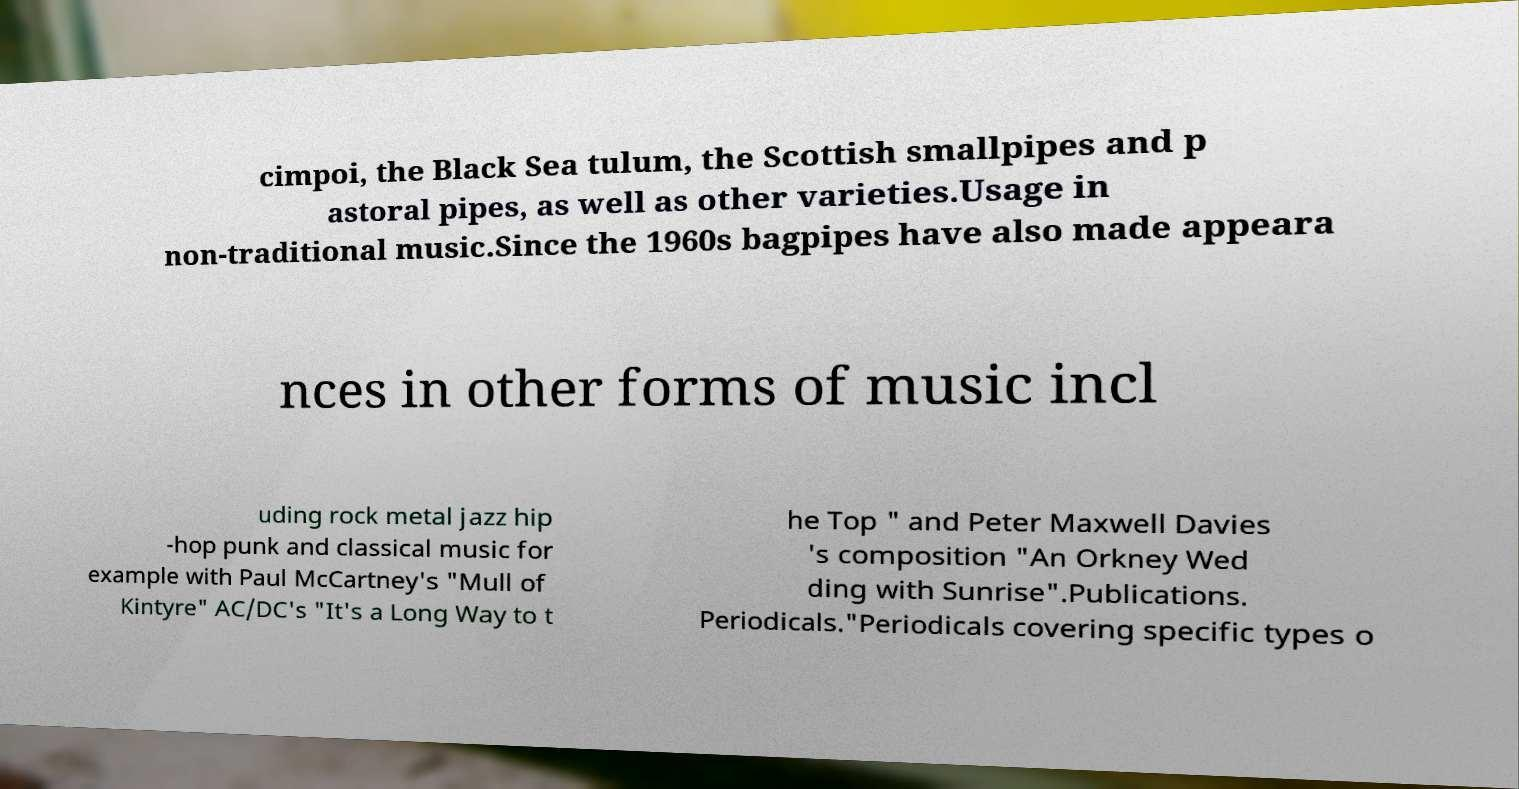Please identify and transcribe the text found in this image. cimpoi, the Black Sea tulum, the Scottish smallpipes and p astoral pipes, as well as other varieties.Usage in non-traditional music.Since the 1960s bagpipes have also made appeara nces in other forms of music incl uding rock metal jazz hip -hop punk and classical music for example with Paul McCartney's "Mull of Kintyre" AC/DC's "It's a Long Way to t he Top " and Peter Maxwell Davies 's composition "An Orkney Wed ding with Sunrise".Publications. Periodicals."Periodicals covering specific types o 